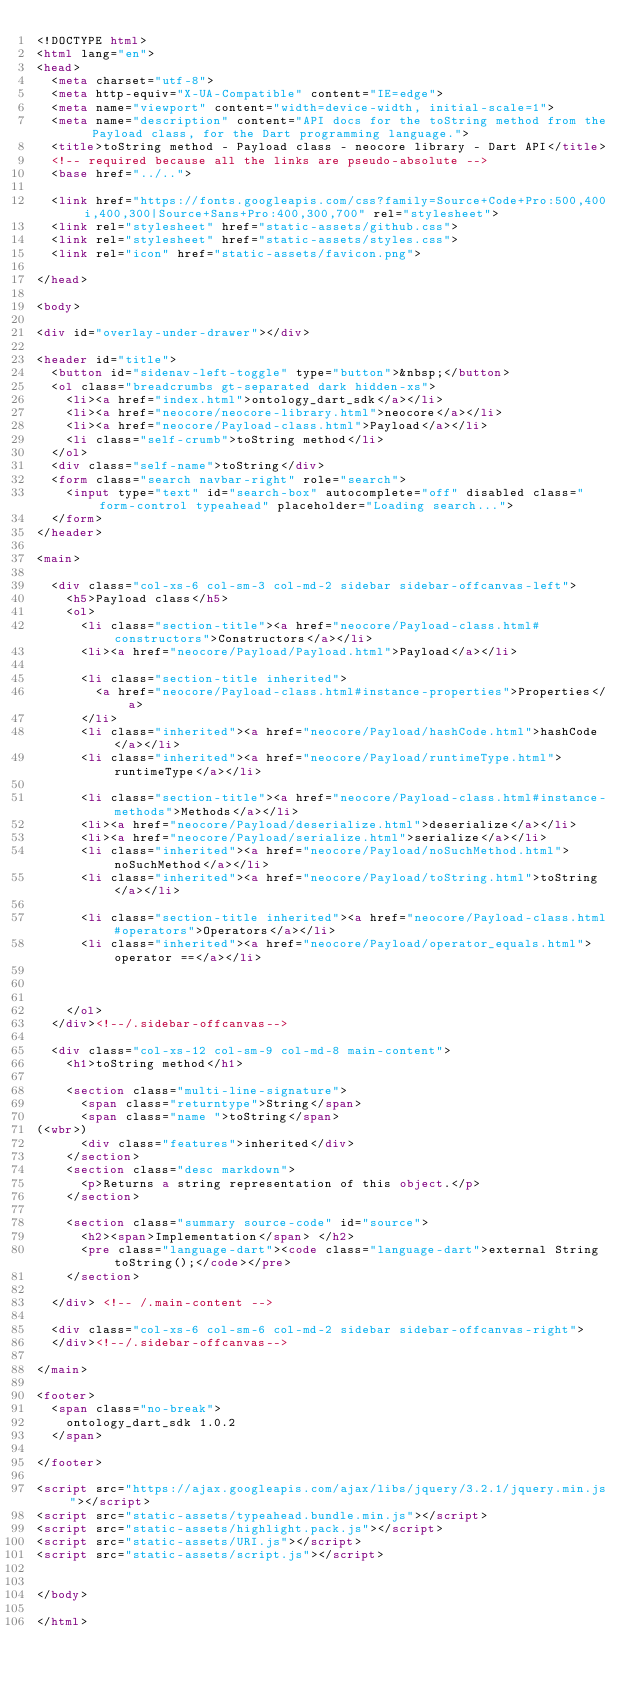<code> <loc_0><loc_0><loc_500><loc_500><_HTML_><!DOCTYPE html>
<html lang="en">
<head>
  <meta charset="utf-8">
  <meta http-equiv="X-UA-Compatible" content="IE=edge">
  <meta name="viewport" content="width=device-width, initial-scale=1">
  <meta name="description" content="API docs for the toString method from the Payload class, for the Dart programming language.">
  <title>toString method - Payload class - neocore library - Dart API</title>
  <!-- required because all the links are pseudo-absolute -->
  <base href="../..">

  <link href="https://fonts.googleapis.com/css?family=Source+Code+Pro:500,400i,400,300|Source+Sans+Pro:400,300,700" rel="stylesheet">
  <link rel="stylesheet" href="static-assets/github.css">
  <link rel="stylesheet" href="static-assets/styles.css">
  <link rel="icon" href="static-assets/favicon.png">

</head>

<body>

<div id="overlay-under-drawer"></div>

<header id="title">
  <button id="sidenav-left-toggle" type="button">&nbsp;</button>
  <ol class="breadcrumbs gt-separated dark hidden-xs">
    <li><a href="index.html">ontology_dart_sdk</a></li>
    <li><a href="neocore/neocore-library.html">neocore</a></li>
    <li><a href="neocore/Payload-class.html">Payload</a></li>
    <li class="self-crumb">toString method</li>
  </ol>
  <div class="self-name">toString</div>
  <form class="search navbar-right" role="search">
    <input type="text" id="search-box" autocomplete="off" disabled class="form-control typeahead" placeholder="Loading search...">
  </form>
</header>

<main>

  <div class="col-xs-6 col-sm-3 col-md-2 sidebar sidebar-offcanvas-left">
    <h5>Payload class</h5>
    <ol>
      <li class="section-title"><a href="neocore/Payload-class.html#constructors">Constructors</a></li>
      <li><a href="neocore/Payload/Payload.html">Payload</a></li>
    
      <li class="section-title inherited">
        <a href="neocore/Payload-class.html#instance-properties">Properties</a>
      </li>
      <li class="inherited"><a href="neocore/Payload/hashCode.html">hashCode</a></li>
      <li class="inherited"><a href="neocore/Payload/runtimeType.html">runtimeType</a></li>
    
      <li class="section-title"><a href="neocore/Payload-class.html#instance-methods">Methods</a></li>
      <li><a href="neocore/Payload/deserialize.html">deserialize</a></li>
      <li><a href="neocore/Payload/serialize.html">serialize</a></li>
      <li class="inherited"><a href="neocore/Payload/noSuchMethod.html">noSuchMethod</a></li>
      <li class="inherited"><a href="neocore/Payload/toString.html">toString</a></li>
    
      <li class="section-title inherited"><a href="neocore/Payload-class.html#operators">Operators</a></li>
      <li class="inherited"><a href="neocore/Payload/operator_equals.html">operator ==</a></li>
    
    
    
    </ol>
  </div><!--/.sidebar-offcanvas-->

  <div class="col-xs-12 col-sm-9 col-md-8 main-content">
    <h1>toString method</h1>

    <section class="multi-line-signature">
      <span class="returntype">String</span>
      <span class="name ">toString</span>
(<wbr>)
      <div class="features">inherited</div>
    </section>
    <section class="desc markdown">
      <p>Returns a string representation of this object.</p>
    </section>
    
    <section class="summary source-code" id="source">
      <h2><span>Implementation</span> </h2>
      <pre class="language-dart"><code class="language-dart">external String toString();</code></pre>
    </section>

  </div> <!-- /.main-content -->

  <div class="col-xs-6 col-sm-6 col-md-2 sidebar sidebar-offcanvas-right">
  </div><!--/.sidebar-offcanvas-->

</main>

<footer>
  <span class="no-break">
    ontology_dart_sdk 1.0.2
  </span>

</footer>

<script src="https://ajax.googleapis.com/ajax/libs/jquery/3.2.1/jquery.min.js"></script>
<script src="static-assets/typeahead.bundle.min.js"></script>
<script src="static-assets/highlight.pack.js"></script>
<script src="static-assets/URI.js"></script>
<script src="static-assets/script.js"></script>


</body>

</html>
</code> 